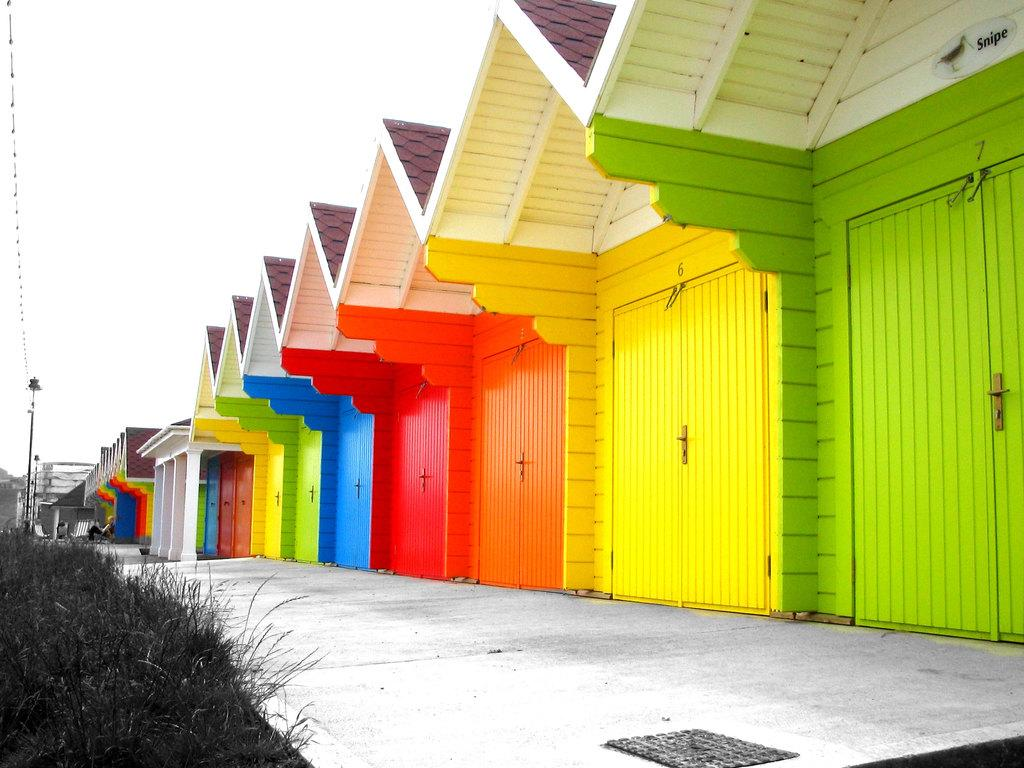What type of structures are visible in the image? There are multiple color buildings in the image. What is located in front of the buildings? A road is in front of the buildings. What type of vegetation is present beside the buildings? Grass is present beside the buildings. What type of haircut is the house in the image getting? There is no house getting a haircut in the image, as the image features buildings and not houses. 